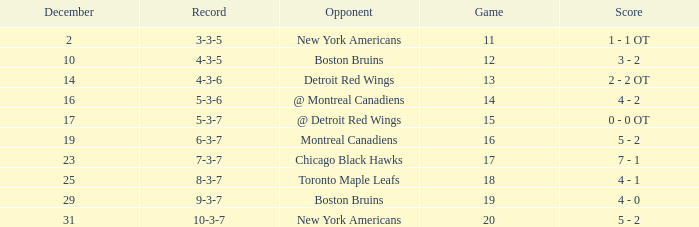Which Game is the highest one that has a Record of 4-3-6? 13.0. 